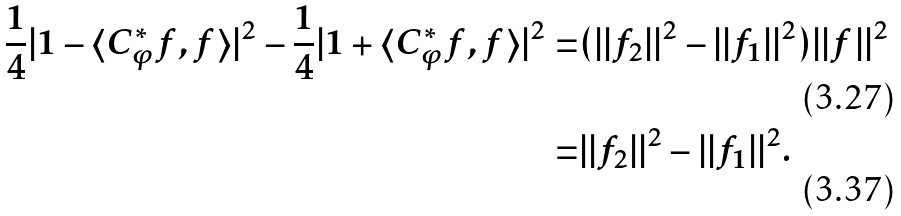<formula> <loc_0><loc_0><loc_500><loc_500>\frac { 1 } { 4 } | 1 - \langle C _ { \varphi } ^ { * } f , f \rangle | ^ { 2 } - \frac { 1 } { 4 } | 1 + \langle C _ { \varphi } ^ { * } f , f \rangle | ^ { 2 } = & ( | | f _ { 2 } | | ^ { 2 } - | | f _ { 1 } | | ^ { 2 } ) | | f | | ^ { 2 } \\ = & | | f _ { 2 } | | ^ { 2 } - | | f _ { 1 } | | ^ { 2 } .</formula> 